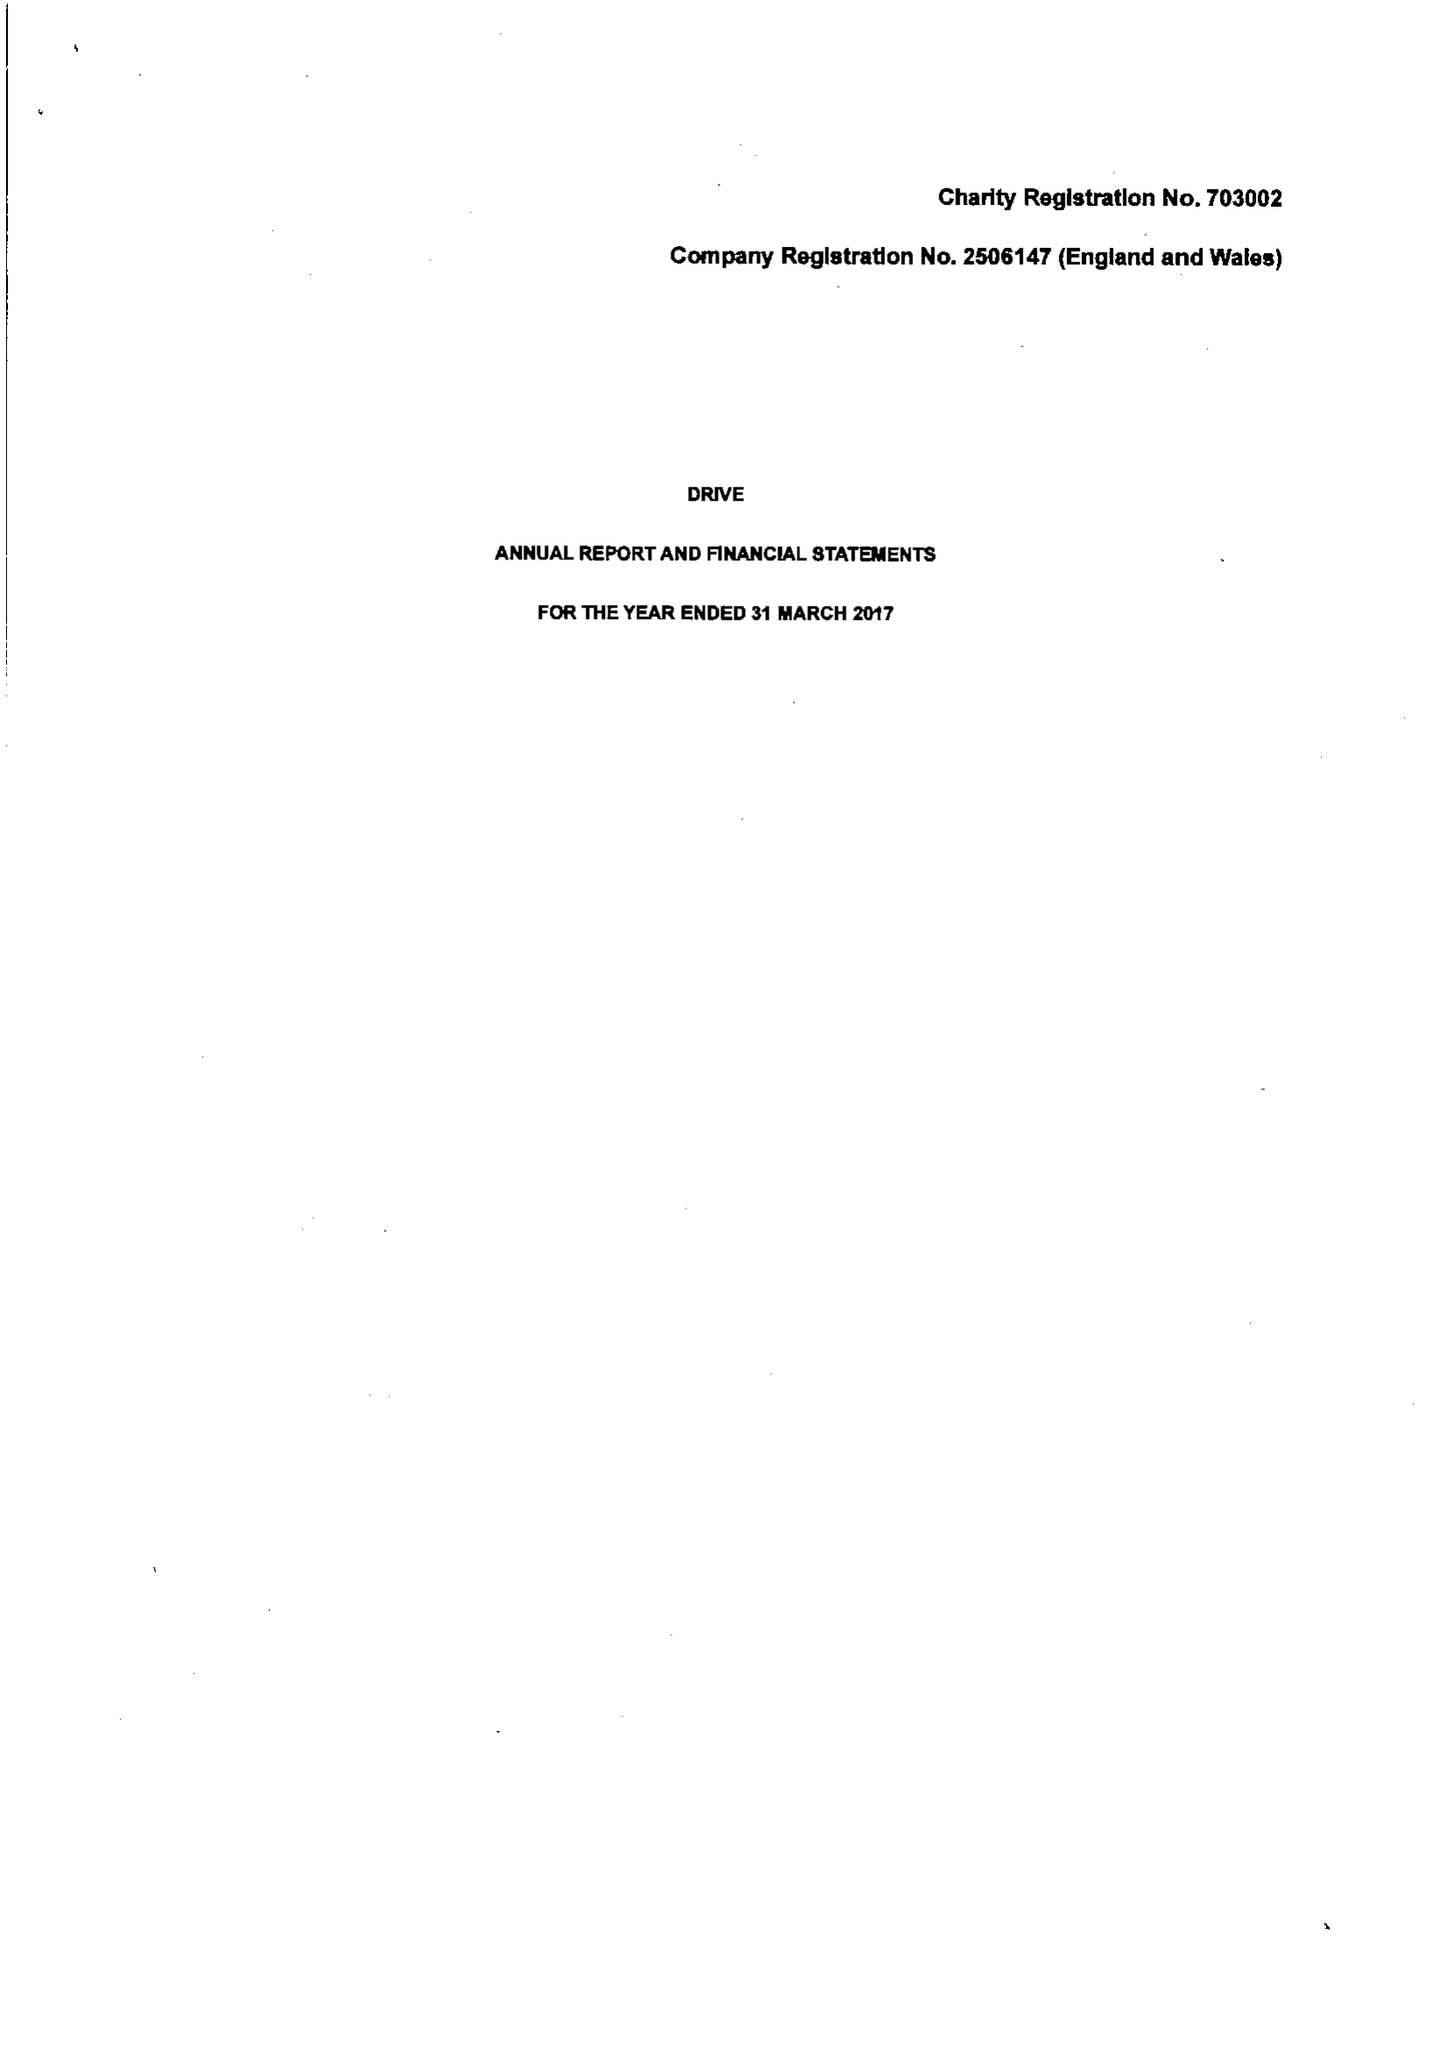What is the value for the address__post_town?
Answer the question using a single word or phrase. None 